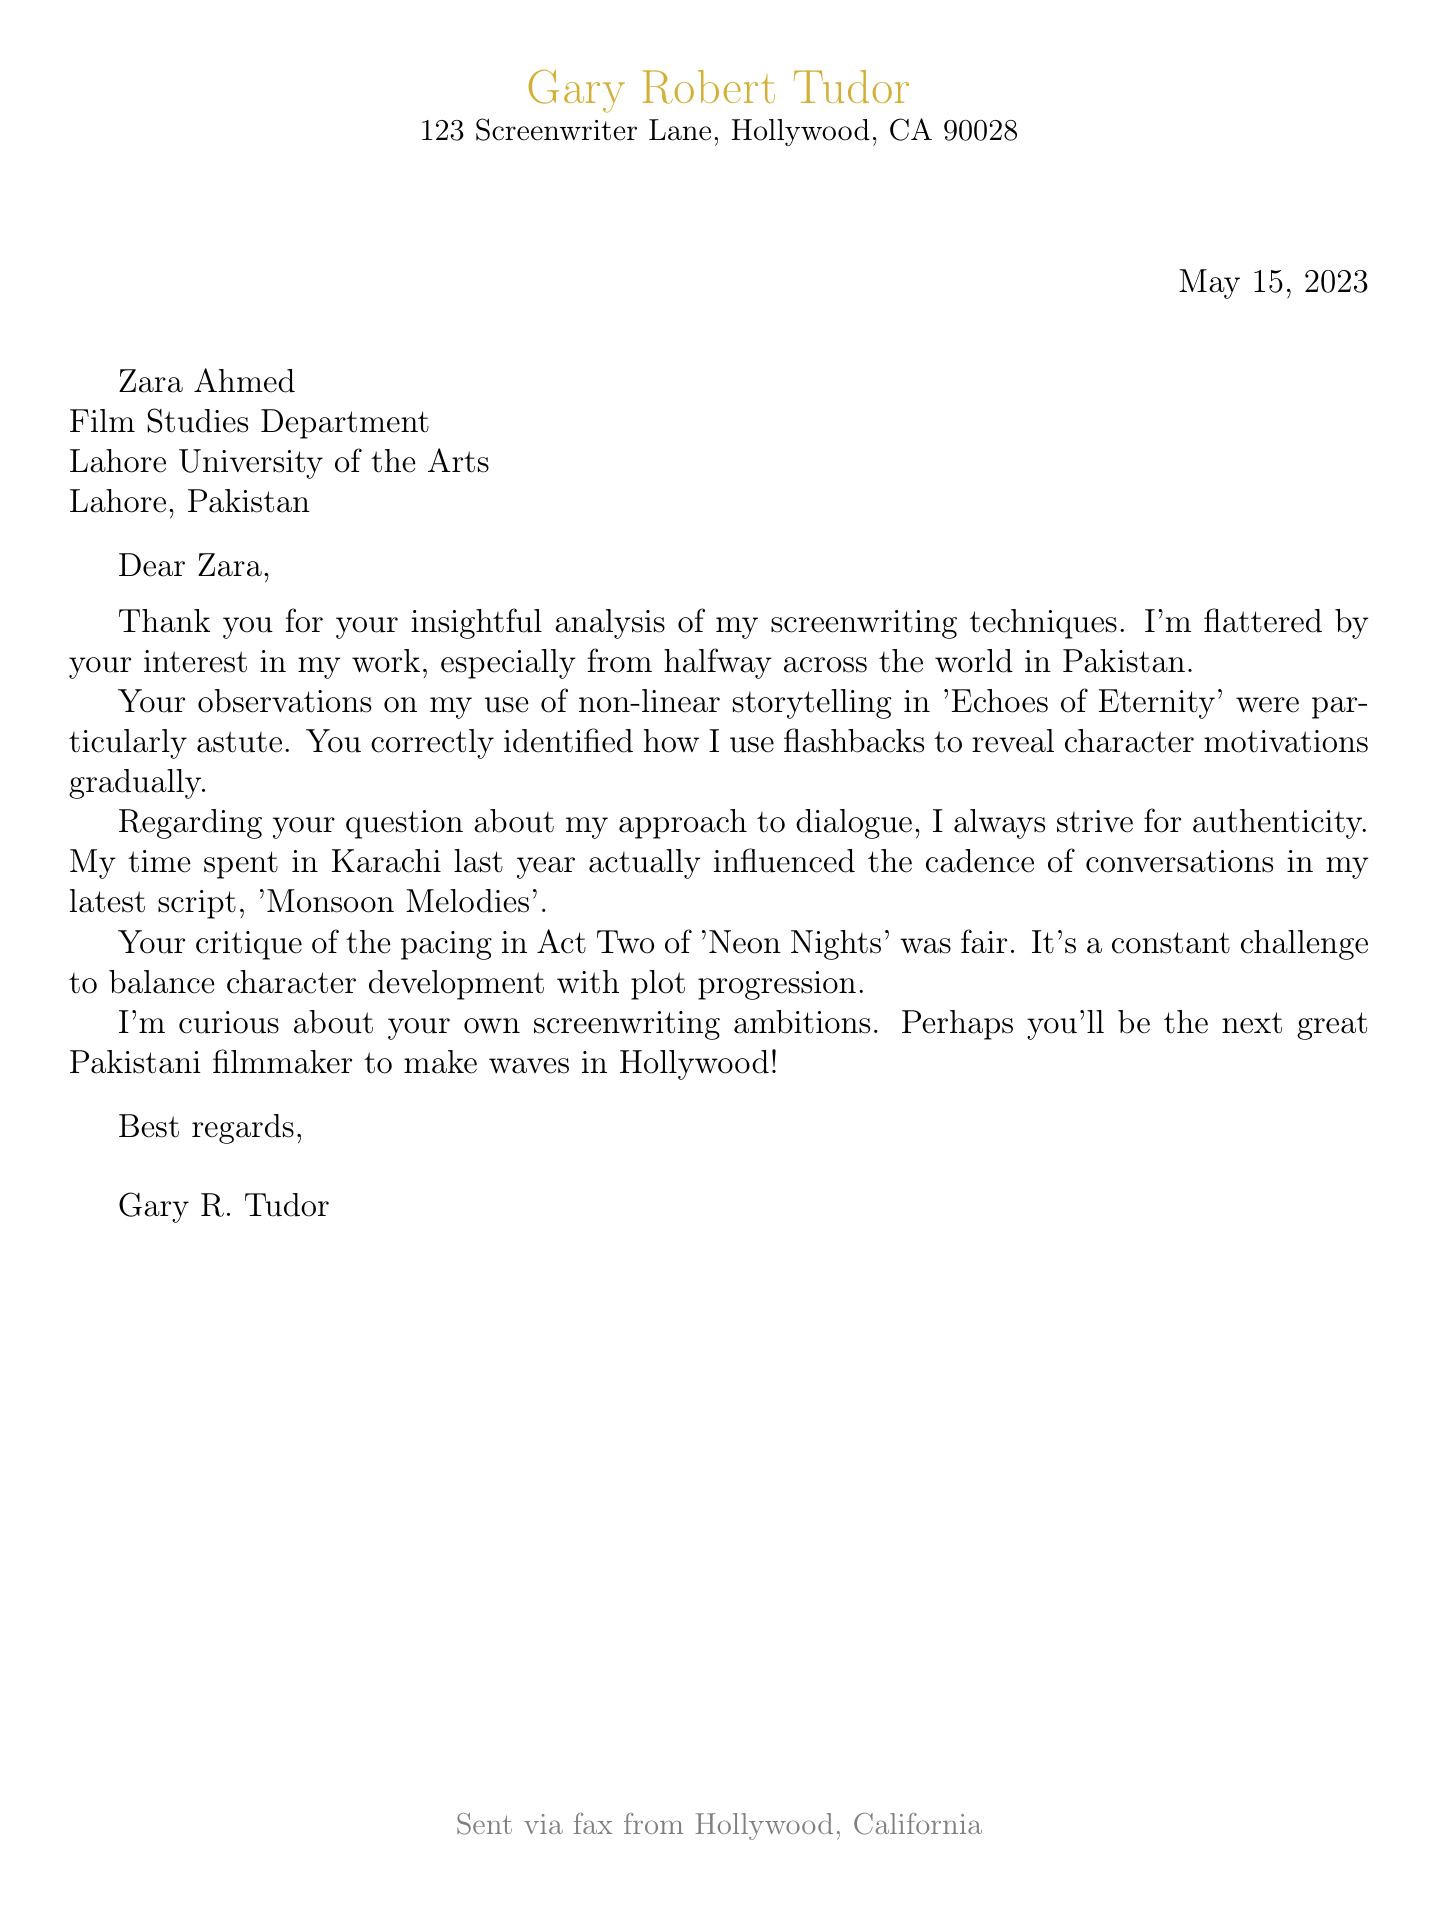What is the name of the sender? The name of the sender, as stated in the document, is Gary Robert Tudor.
Answer: Gary Robert Tudor What date was the letter sent? The date indicated in the letter is May 15, 2023.
Answer: May 15, 2023 Who is the recipient of the letter? The letter is addressed to Zara Ahmed.
Answer: Zara Ahmed What is the title of the script cited regarding dialogue? The script mentioned in relation to dialogue is 'Monsoon Melodies'.
Answer: Monsoon Melodies What city is the recipient located in? The recipient, Zara Ahmed, is situated in Lahore, Pakistan.
Answer: Lahore How does Tudor describe his experience in Karachi? Tudor notes that his time spent in Karachi influenced the cadence of conversations in his latest script.
Answer: Influenced the cadence What screenplay did Zara comment on regarding pacing? Zara critiqued the pacing in Act Two of 'Neon Nights'.
Answer: Neon Nights What kind of storytelling is used in 'Echoes of Eternity'? The document describes the use of non-linear storytelling in 'Echoes of Eternity'.
Answer: Non-linear storytelling What action does Tudor express curiosity about? Tudor expresses curiosity about Zara's screenwriting ambitions.
Answer: Screenwriting ambitions 